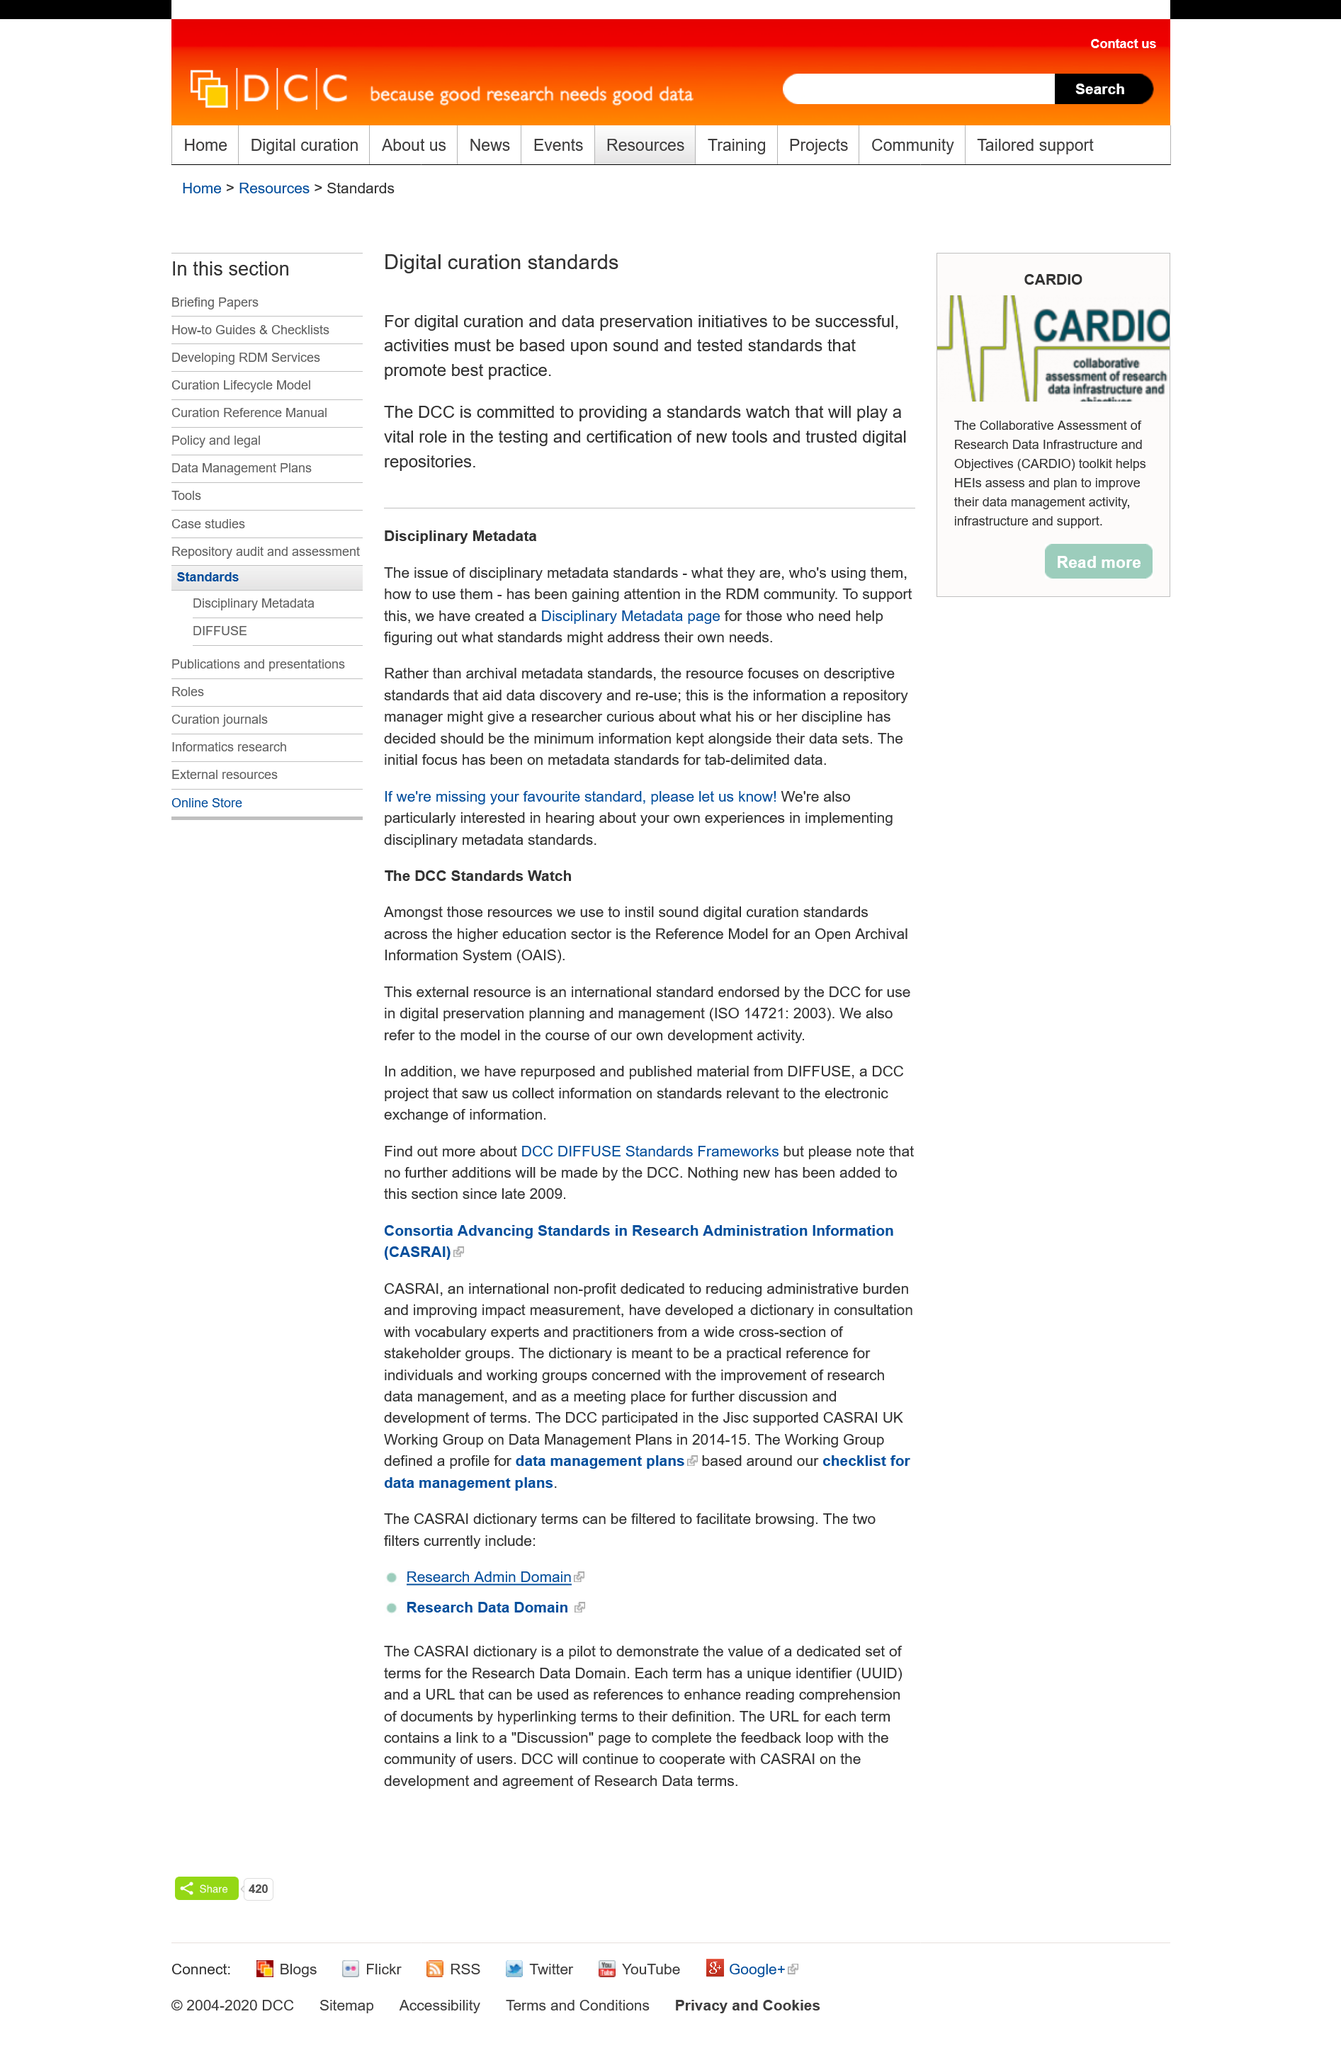Highlight a few significant elements in this photo. The Disciplinary Metadata page focuses on descriptive standards that aid data discovery and re-use for a specific domain or discipline. The issue of disciplinary metadata standards has been gaining attention in the RDM (Research Data Management) community. This page is about digital curation standards. The Working Group's data management plans are based on a checklist for data management plans. CASRAI is an acronym that stands for "Consortia Advancing Standards in Research Administration Information. 